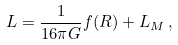<formula> <loc_0><loc_0><loc_500><loc_500>L = \frac { 1 } { 1 6 \pi G } f ( R ) + L _ { M } \, ,</formula> 